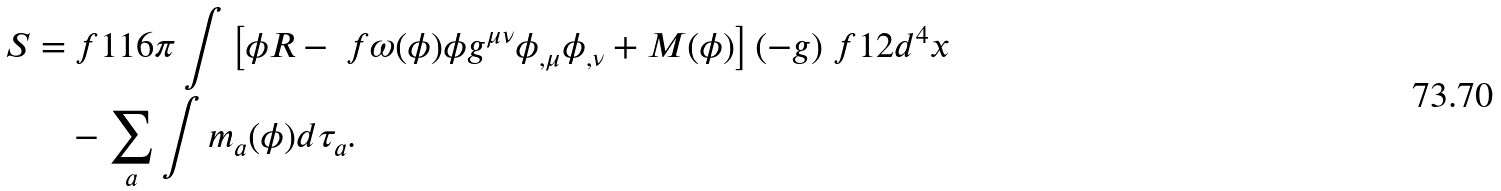Convert formula to latex. <formula><loc_0><loc_0><loc_500><loc_500>S = & \ f { 1 } { 1 6 \pi } \int \left [ \phi R - \ f { \omega ( \phi ) } { \phi } g ^ { \mu \nu } \phi _ { , \mu } \phi _ { , \nu } + M ( \phi ) \right ] ( - g ) ^ { \ } f { 1 } { 2 } d ^ { 4 } x \\ & - \sum _ { a } \int m _ { a } ( \phi ) d \tau _ { a } .</formula> 